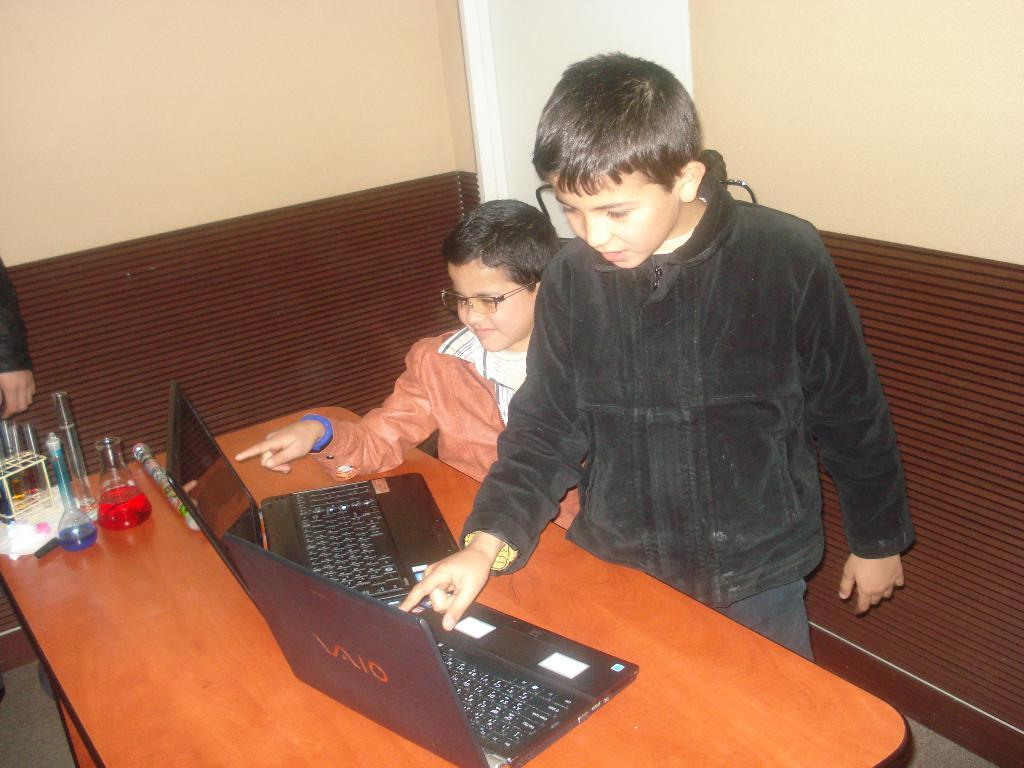How many men are standing in the image? There are two men standing in the image. What objects are on the table in the image? There are two laptops and glass jars on the table in the image. Where is the yak located in the image? There is no yak present in the image. What type of shop can be seen in the background of the image? There is no shop visible in the image. 